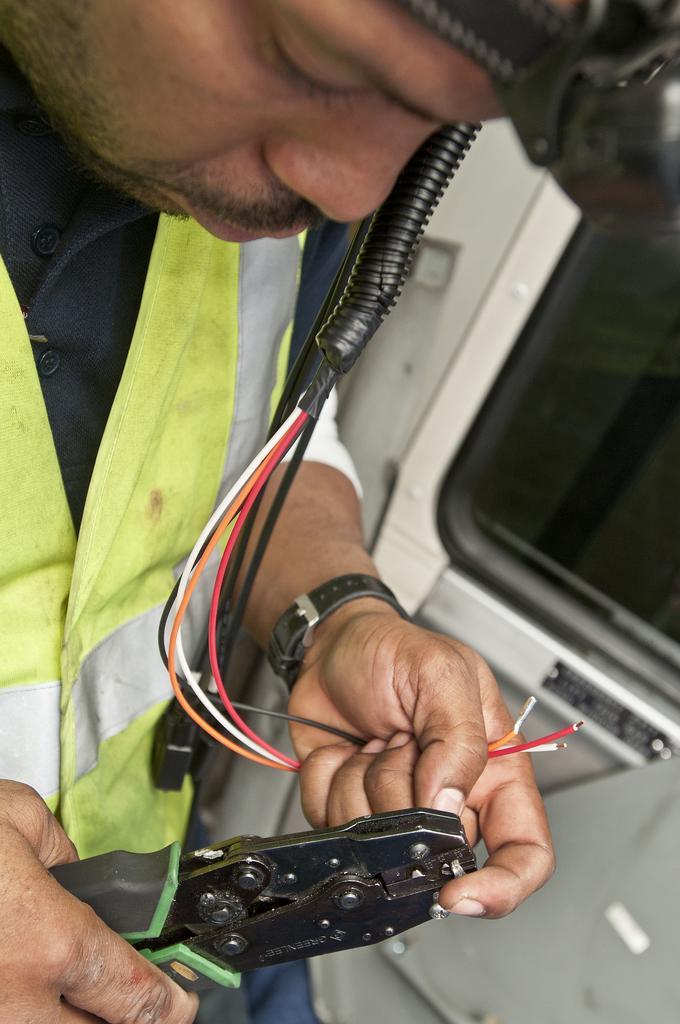Describe this image in one or two sentences. In this image I can see a person wearing black, green, grey and blue colored dress is standing and holding few wires and a tool in his hand. In the background I can see few objects. 